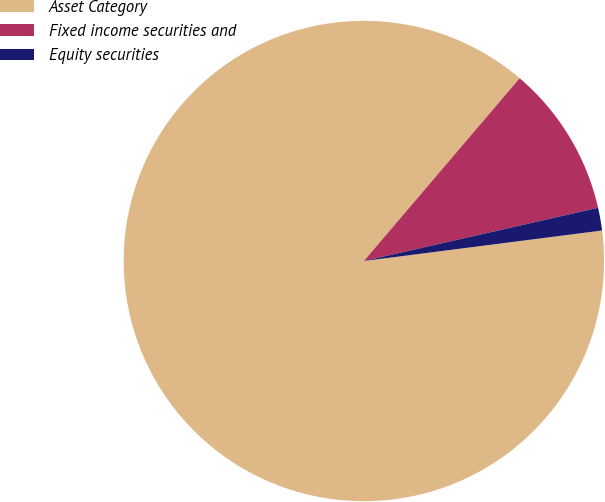Convert chart to OTSL. <chart><loc_0><loc_0><loc_500><loc_500><pie_chart><fcel>Asset Category<fcel>Fixed income securities and<fcel>Equity securities<nl><fcel>88.26%<fcel>10.21%<fcel>1.53%<nl></chart> 